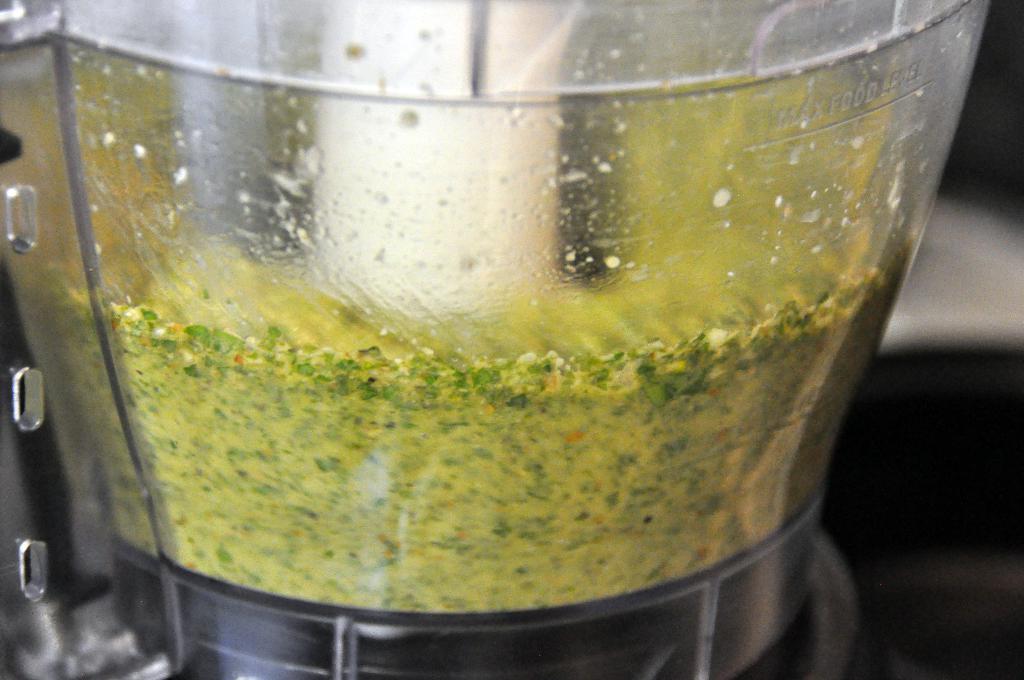Describe this image in one or two sentences. In the foreground of this picture, there is a glass container in which some food is placed and there is also a max food level mark on it. 